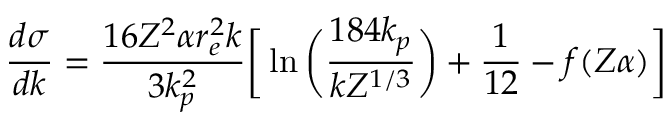<formula> <loc_0><loc_0><loc_500><loc_500>{ \frac { d \sigma } { d k } } = { \frac { 1 6 Z ^ { 2 } \alpha r _ { e } ^ { 2 } k } { 3 k _ { p } ^ { 2 } } } \left [ \ln { \left ( { \frac { 1 8 4 k _ { p } } { k Z ^ { 1 / 3 } } } \right ) } + { \frac { 1 } { 1 2 } } - f ( Z \alpha ) \right ]</formula> 